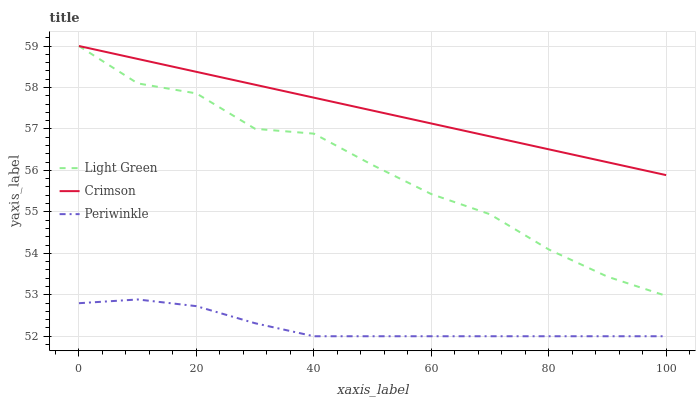Does Periwinkle have the minimum area under the curve?
Answer yes or no. Yes. Does Crimson have the maximum area under the curve?
Answer yes or no. Yes. Does Light Green have the minimum area under the curve?
Answer yes or no. No. Does Light Green have the maximum area under the curve?
Answer yes or no. No. Is Crimson the smoothest?
Answer yes or no. Yes. Is Light Green the roughest?
Answer yes or no. Yes. Is Periwinkle the smoothest?
Answer yes or no. No. Is Periwinkle the roughest?
Answer yes or no. No. Does Periwinkle have the lowest value?
Answer yes or no. Yes. Does Light Green have the lowest value?
Answer yes or no. No. Does Light Green have the highest value?
Answer yes or no. Yes. Does Periwinkle have the highest value?
Answer yes or no. No. Is Periwinkle less than Light Green?
Answer yes or no. Yes. Is Crimson greater than Periwinkle?
Answer yes or no. Yes. Does Light Green intersect Crimson?
Answer yes or no. Yes. Is Light Green less than Crimson?
Answer yes or no. No. Is Light Green greater than Crimson?
Answer yes or no. No. Does Periwinkle intersect Light Green?
Answer yes or no. No. 